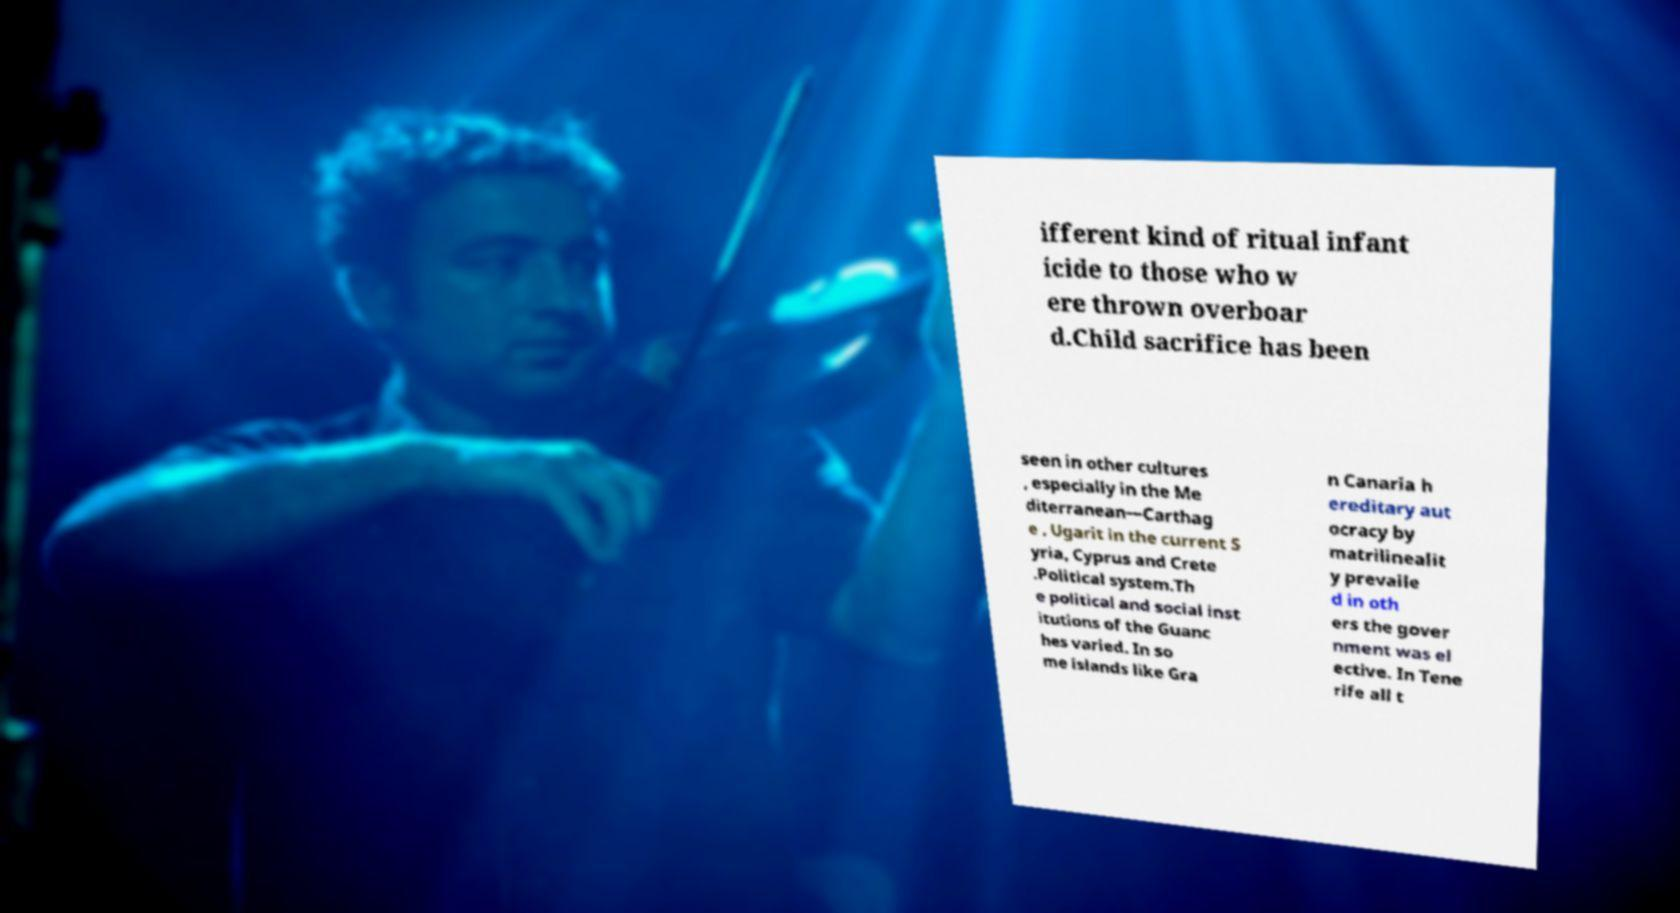I need the written content from this picture converted into text. Can you do that? ifferent kind of ritual infant icide to those who w ere thrown overboar d.Child sacrifice has been seen in other cultures , especially in the Me diterranean—Carthag e , Ugarit in the current S yria, Cyprus and Crete .Political system.Th e political and social inst itutions of the Guanc hes varied. In so me islands like Gra n Canaria h ereditary aut ocracy by matrilinealit y prevaile d in oth ers the gover nment was el ective. In Tene rife all t 